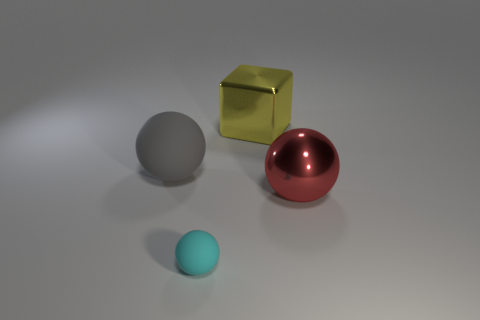Do the cyan matte ball and the yellow object have the same size?
Your response must be concise. No. There is a metal thing that is to the right of the metal block; is there a metallic block to the right of it?
Keep it short and to the point. No. There is a large thing in front of the large gray rubber sphere; what shape is it?
Your response must be concise. Sphere. There is a thing that is behind the gray matte object left of the yellow block; how many metallic objects are in front of it?
Provide a succinct answer. 1. There is a metallic sphere; is its size the same as the rubber object behind the tiny cyan matte ball?
Your answer should be very brief. Yes. There is a sphere in front of the shiny thing in front of the gray object; what size is it?
Provide a succinct answer. Small. How many big purple spheres have the same material as the gray sphere?
Offer a very short reply. 0. Is there a blue matte cube?
Provide a succinct answer. No. What size is the matte thing that is on the right side of the gray thing?
Your answer should be compact. Small. What number of objects have the same color as the block?
Provide a short and direct response. 0. 